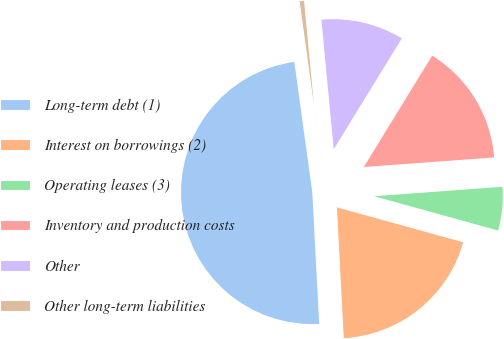<chart> <loc_0><loc_0><loc_500><loc_500><pie_chart><fcel>Long-term debt (1)<fcel>Interest on borrowings (2)<fcel>Operating leases (3)<fcel>Inventory and production costs<fcel>Other<fcel>Other long-term liabilities<nl><fcel>48.66%<fcel>19.87%<fcel>5.47%<fcel>15.07%<fcel>10.27%<fcel>0.67%<nl></chart> 